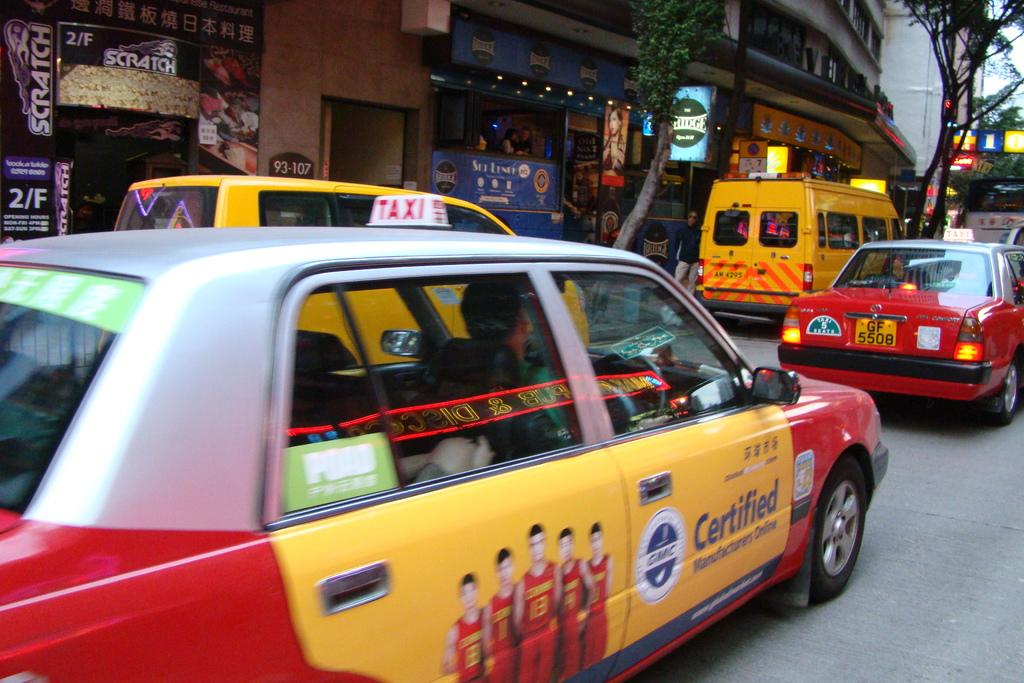Is this taxi certified?
Offer a very short reply. Yes. What type of car is that?
Your response must be concise. Taxi. 